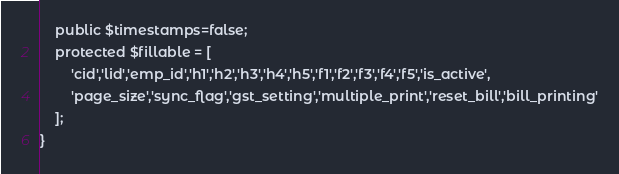<code> <loc_0><loc_0><loc_500><loc_500><_PHP_>    public $timestamps=false;
    protected $fillable = [
        'cid','lid','emp_id','h1','h2','h3','h4','h5','f1','f2','f3','f4','f5','is_active',
        'page_size','sync_flag','gst_setting','multiple_print','reset_bill','bill_printing'
    ];
}
</code> 